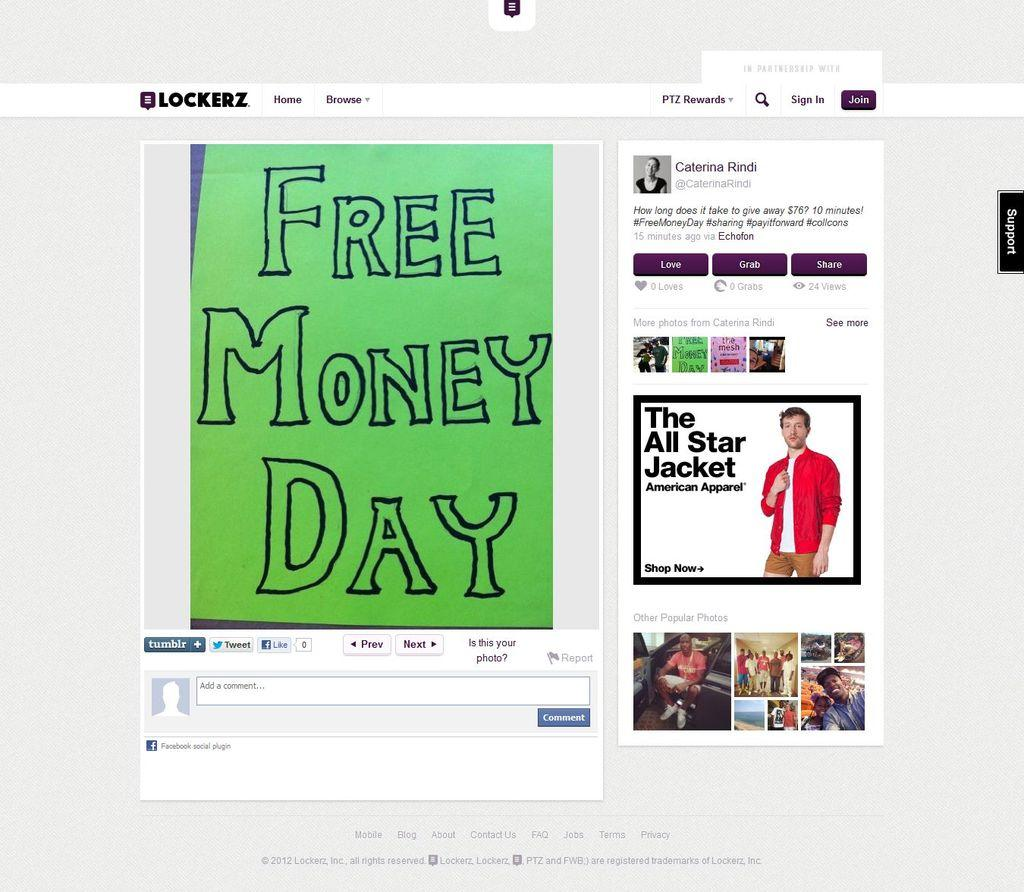<image>
Give a short and clear explanation of the subsequent image. A website contains an article talking about an event called free money day. 